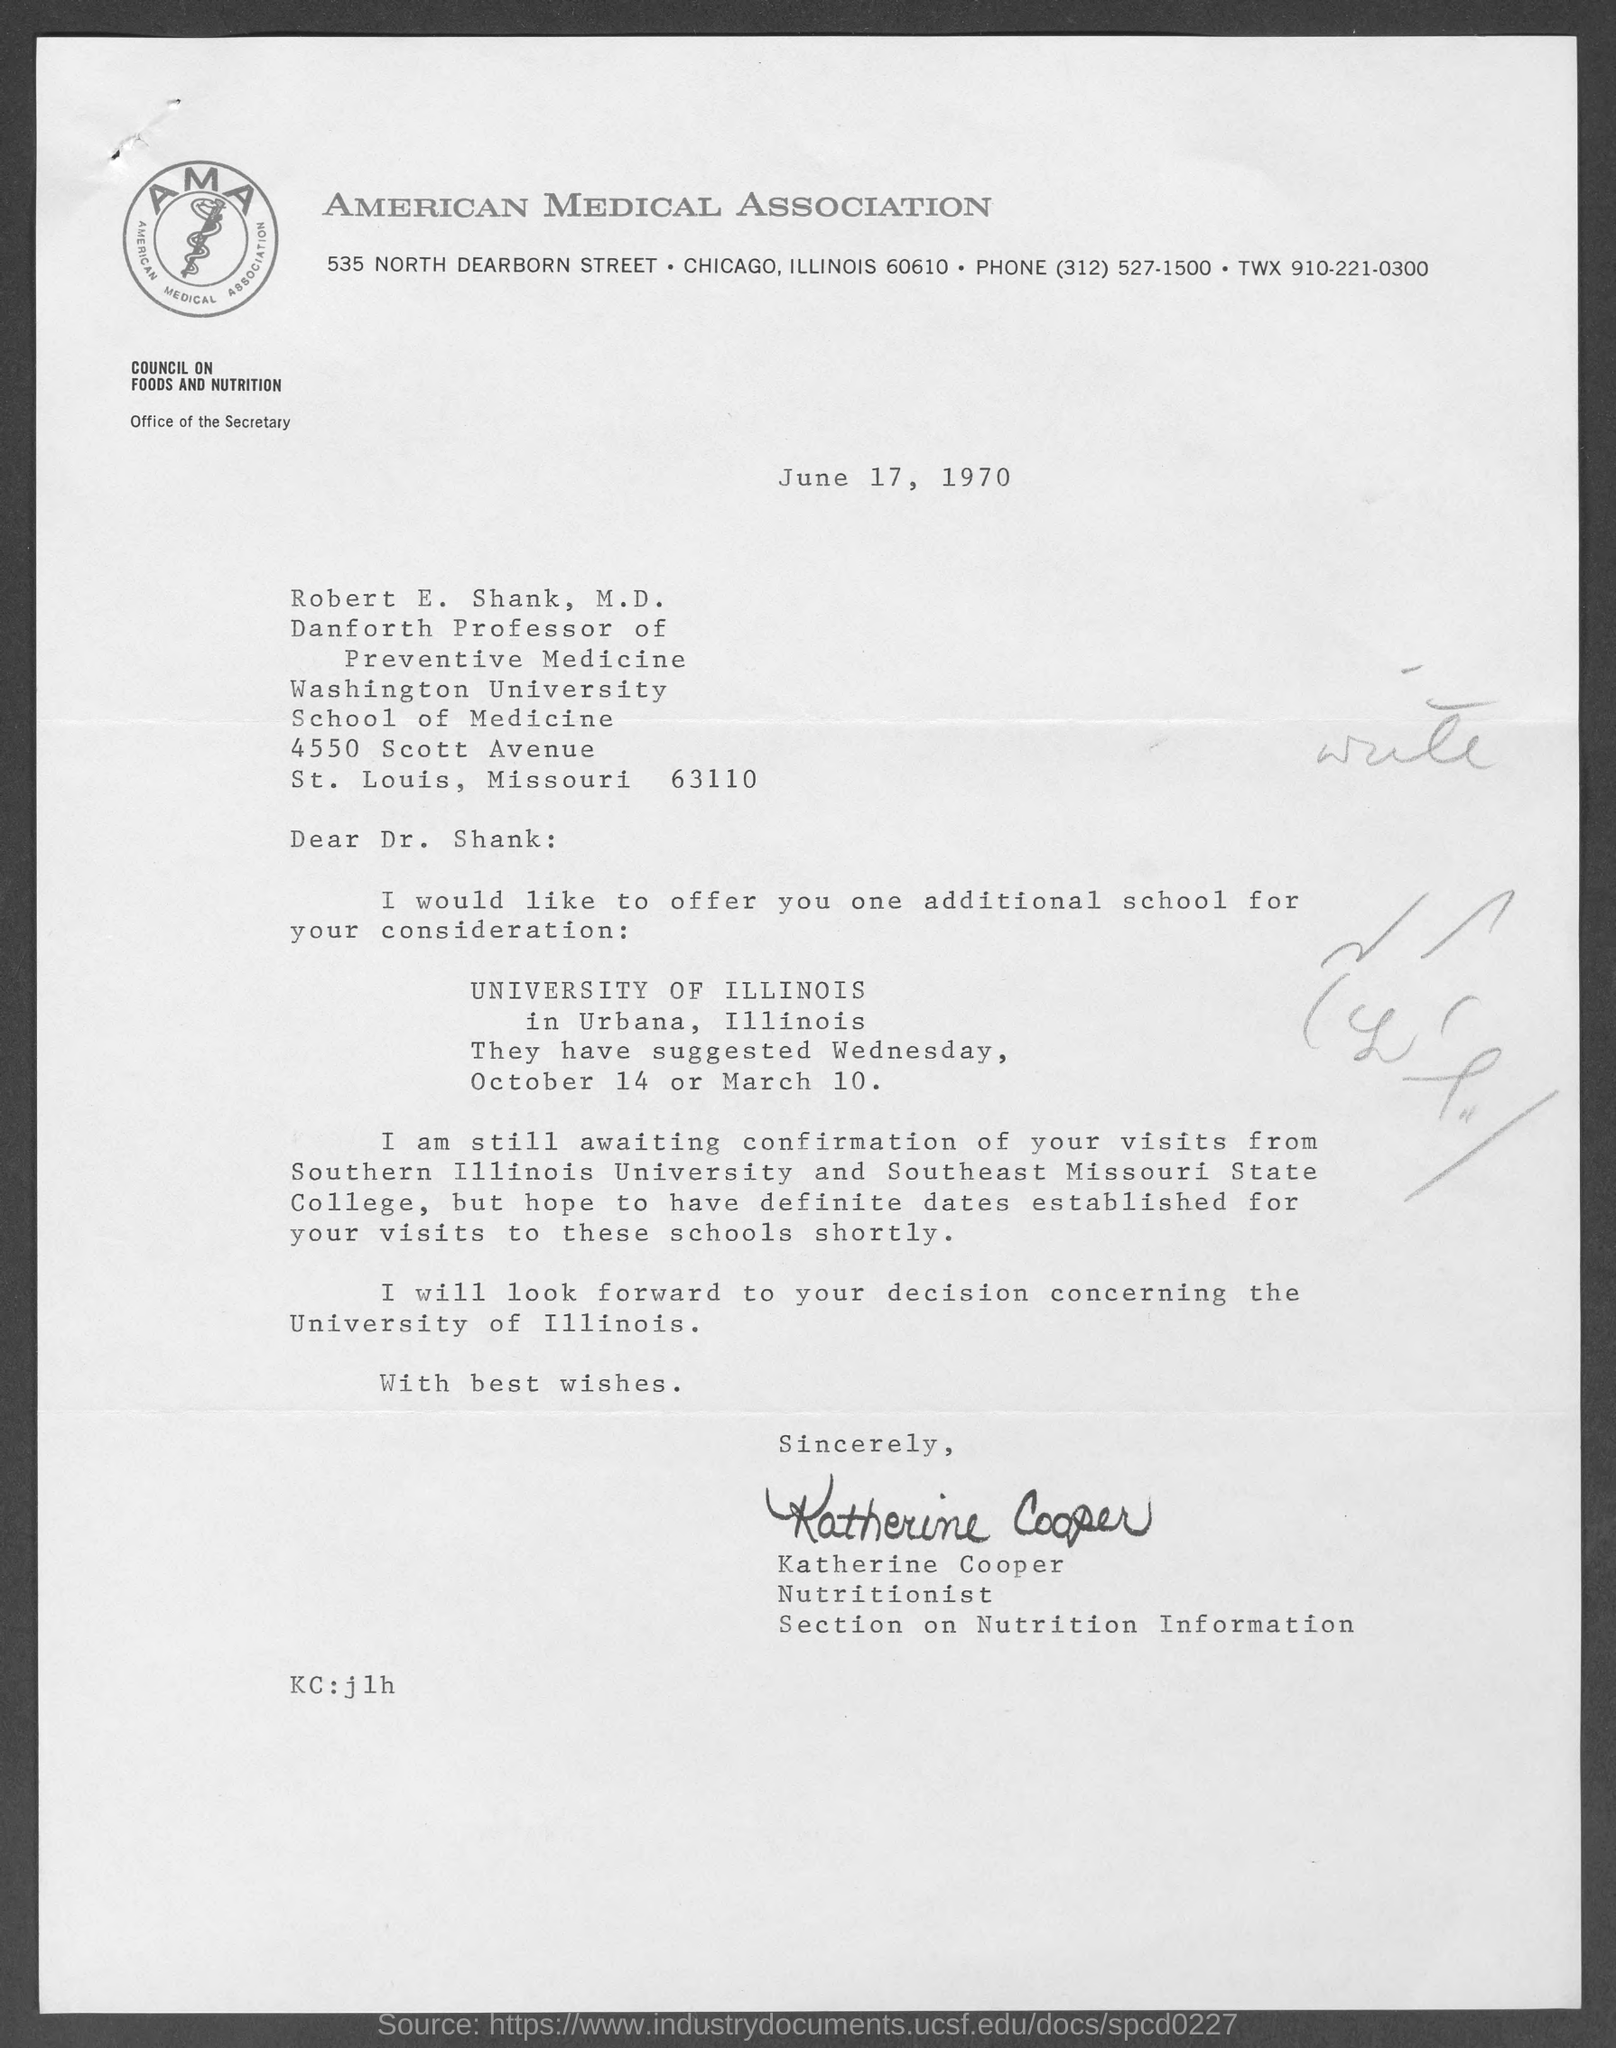Draw attention to some important aspects in this diagram. The American Medical Association is mentioned on the letterhead. The sender of this letter is Katherine Cooper. Robert E. Shank, M.D. holds the designation of Danforth Professor of Preventive Medicine. The date mentioned in this letter is June 17, 1970. 